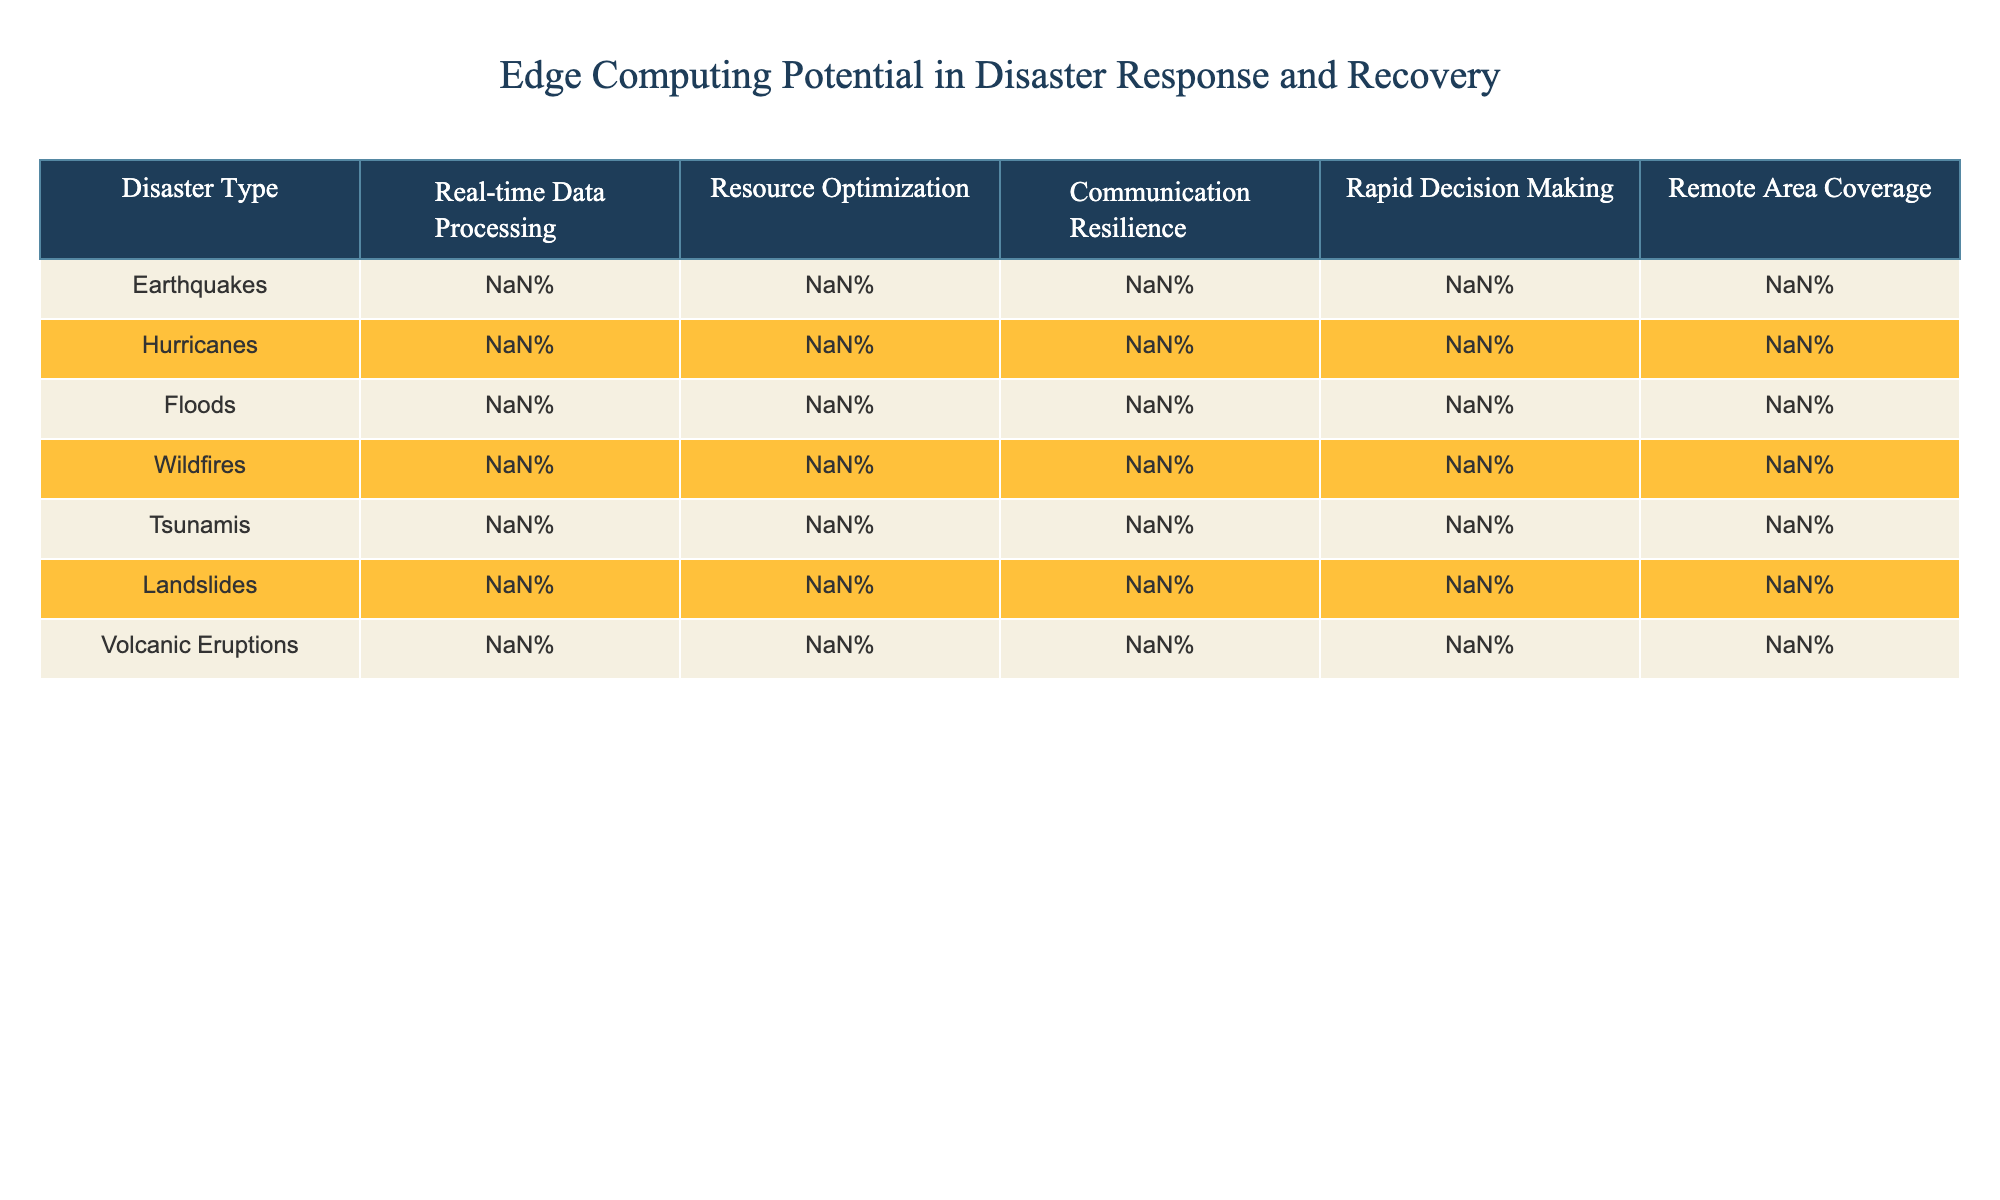What percentage of resource optimization is noted for wildfires? Looking at the row for wildfires, the value under resource optimization is 75%.
Answer: 75% Which disaster type shows the highest percentage for communication resilience? The disaster type with the highest percentage for communication resilience is tsunamis, with a value of 95%.
Answer: Tsunamis What is the average percentage of rapid decision-making across all disaster types? To find the average, we add the rapid decision-making percentages: (95 + 85 + 80 + 90 + 85 + 75 + 95 + 80) = 700, and divide by 8 (the total number of disaster types), giving us an average of 87.5%.
Answer: 87.5% Is the percentage of remote area coverage for floods greater than that for earthquakes? The percentage for floods in remote area coverage is 85%, while for earthquakes, it is 80%. Since 85% is greater than 80%, the statement is true.
Answer: Yes What is the difference in real-time data processing between wildfires and hurricanes? Wildfires have a real-time data processing percentage of 95%, and hurricanes have 85%. The difference is 95 - 85 = 10%.
Answer: 10% For which disaster type is there a significant drop in both resource optimization and rapid decision-making? In the case of wildfires, resource optimization drops to 75% and rapid decision-making is 90%. This appears to be the significant drop relative to other types.
Answer: Wildfires Which disaster has the lowest percentage of resource optimization and what is the value? The disaster type with the lowest percentage of resource optimization is wildfires, with a value of 75%.
Answer: 75% If we analyze earthquakes and volcanic eruptions, which one has higher overall percentages for all criteria combined? We calculate the total for earthquakes: (90 + 85 + 75 + 95 + 80) = 425, and for volcanic eruptions: (85 + 80 + 75 + 95 + 85) = 420. Thus, earthquakes have a higher overall total.
Answer: Earthquakes How does the percentage of real-time data processing for tsunamis compare to that of landslides? Tsunamis have a real-time data processing percentage of 80%, while landslides have 70%. Therefore, tsunamis have a higher percentage.
Answer: Higher Which two disaster types have similar values for remote area coverage, and what are those values? Looking at the table, both landslides and wildfires have a remote area coverage of 90%.
Answer: 90% 